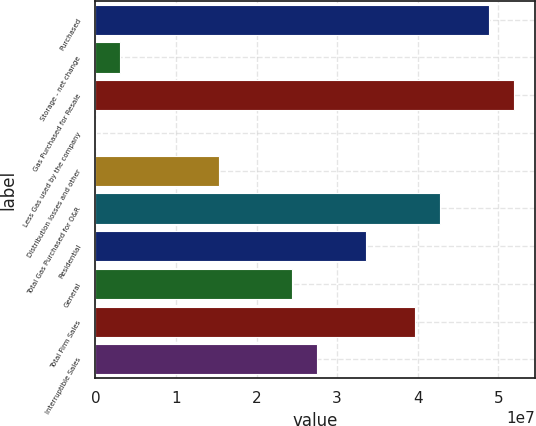Convert chart to OTSL. <chart><loc_0><loc_0><loc_500><loc_500><bar_chart><fcel>Purchased<fcel>Storage - net change<fcel>Gas Purchased for Resale<fcel>Less Gas used by the company<fcel>Distribution losses and other<fcel>Total Gas Purchased for O&R<fcel>Residential<fcel>General<fcel>Total Firm Sales<fcel>Interruptible Sales<nl><fcel>4.88566e+07<fcel>3.09892e+06<fcel>5.19071e+07<fcel>48410<fcel>1.5301e+07<fcel>4.27555e+07<fcel>3.3604e+07<fcel>2.44525e+07<fcel>3.9705e+07<fcel>2.7503e+07<nl></chart> 